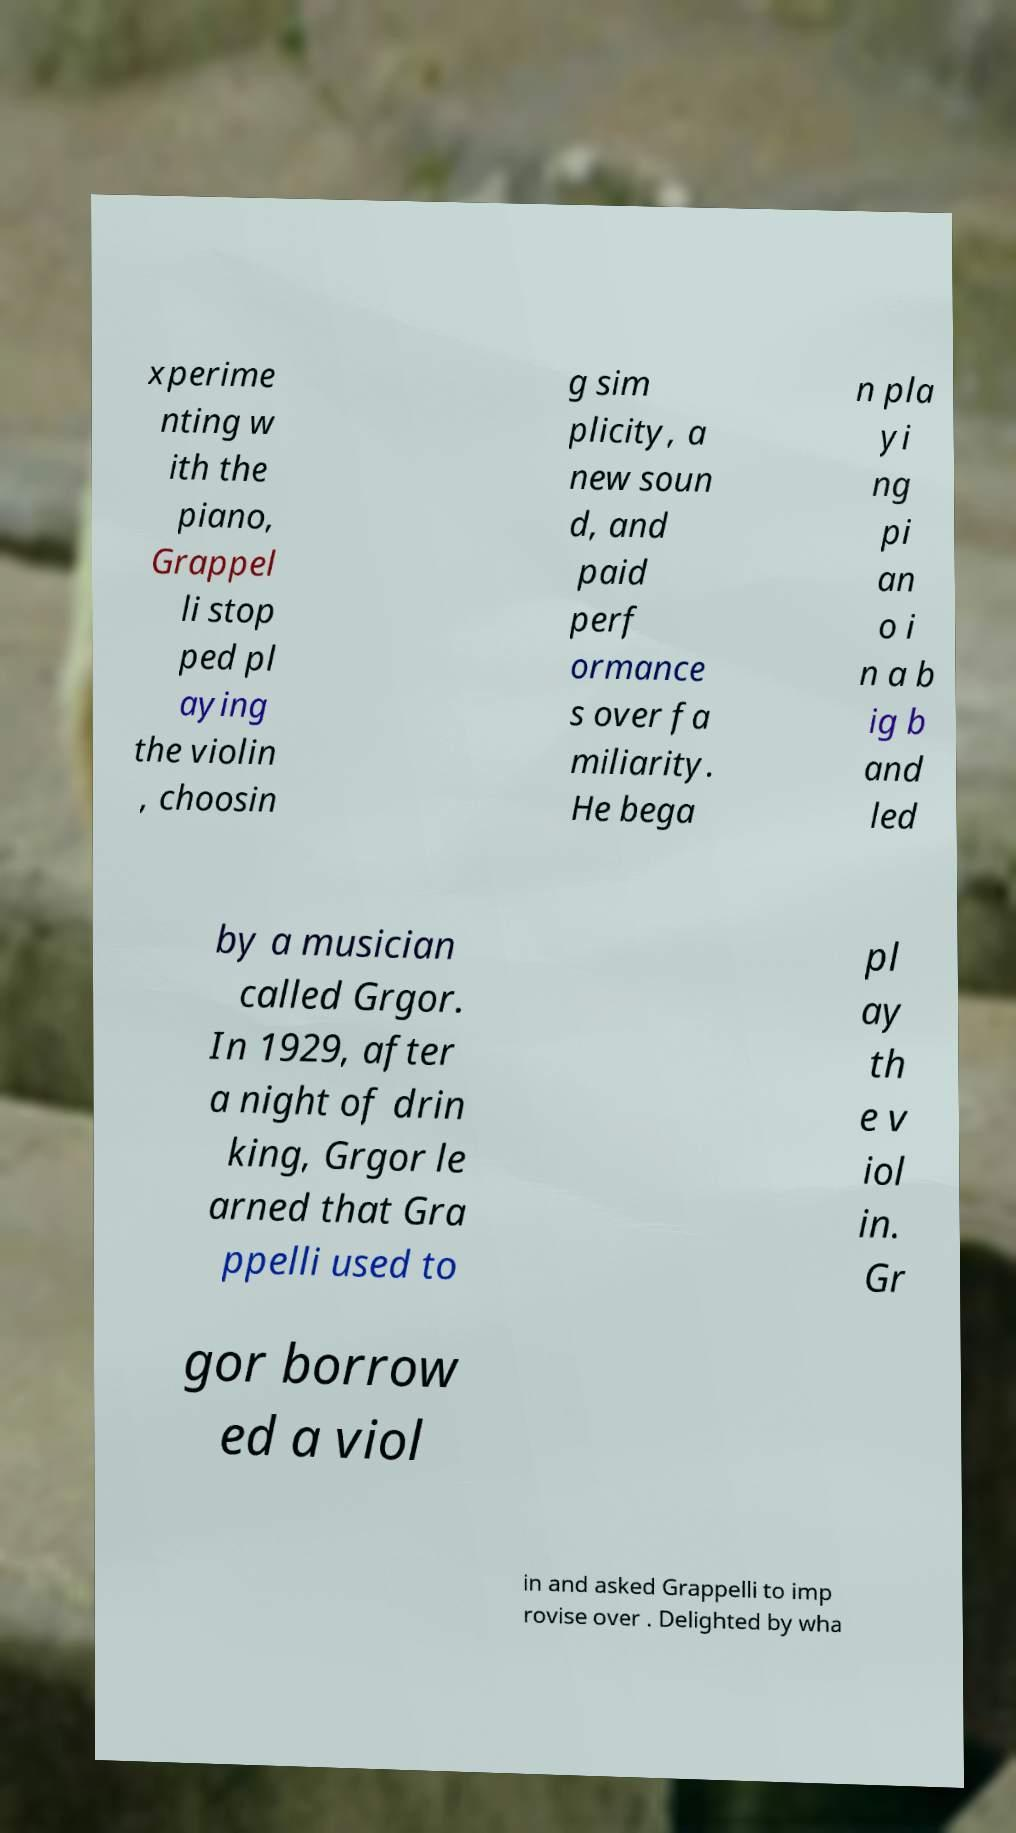Please read and relay the text visible in this image. What does it say? xperime nting w ith the piano, Grappel li stop ped pl aying the violin , choosin g sim plicity, a new soun d, and paid perf ormance s over fa miliarity. He bega n pla yi ng pi an o i n a b ig b and led by a musician called Grgor. In 1929, after a night of drin king, Grgor le arned that Gra ppelli used to pl ay th e v iol in. Gr gor borrow ed a viol in and asked Grappelli to imp rovise over . Delighted by wha 